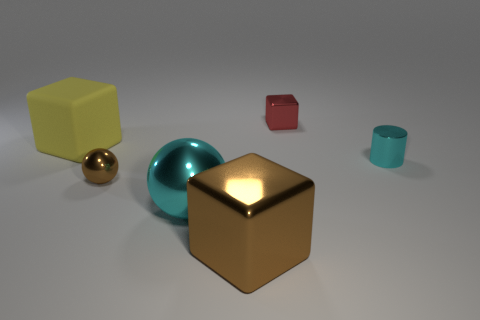What number of objects are either red shiny blocks that are behind the small brown sphere or rubber things?
Offer a terse response. 2. Are there more cubes than metal objects?
Offer a terse response. No. Are there any cyan objects of the same size as the brown ball?
Your answer should be very brief. Yes. How many things are large cyan spheres in front of the tiny cyan object or objects that are behind the large yellow block?
Provide a short and direct response. 2. What color is the big metallic object left of the block that is in front of the tiny sphere?
Your answer should be very brief. Cyan. The cylinder that is the same material as the brown block is what color?
Your answer should be compact. Cyan. How many spheres have the same color as the small metallic block?
Give a very brief answer. 0. How many objects are either small cyan cylinders or red matte things?
Ensure brevity in your answer.  1. There is a yellow thing that is the same size as the brown block; what shape is it?
Offer a terse response. Cube. How many metallic blocks are both in front of the yellow matte object and behind the large brown block?
Your answer should be very brief. 0. 